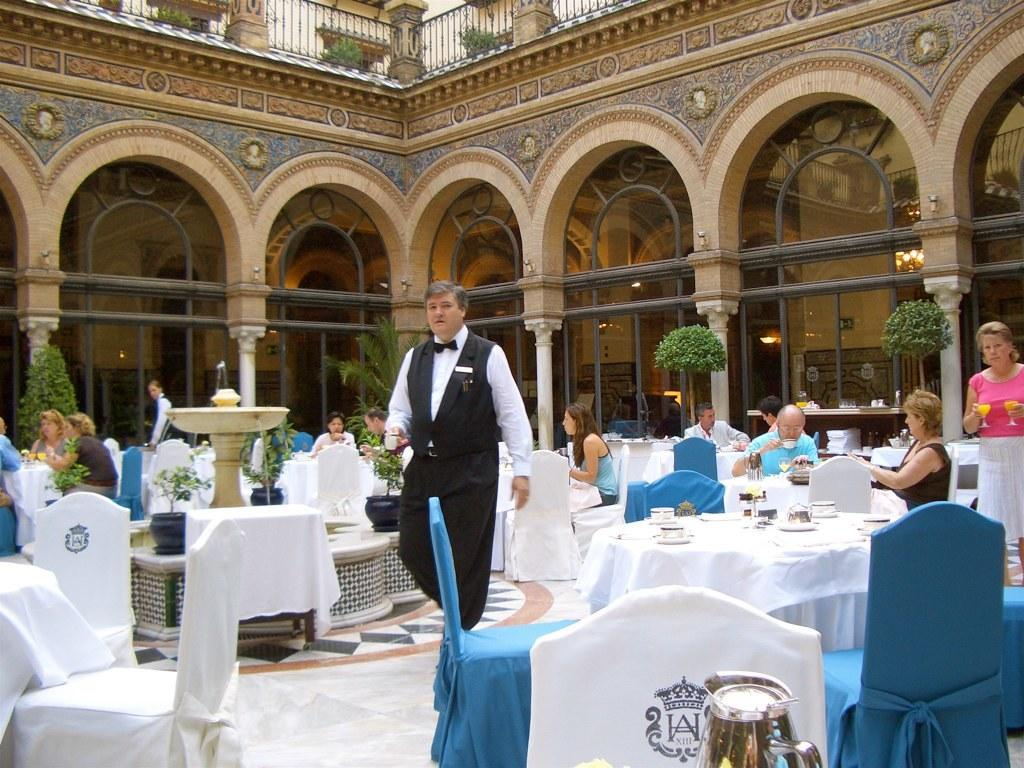What is the man in the image doing? The man is walking in the image. On what surface is the man walking? The man is walking on the floor. What is the position of the woman in the image? The woman is standing in the background of the image. What are some people in the image doing? There are people sitting in the image. What type of plant is present in the image? There is a small tree in the image. What is a feature of the setting in the image? There is a wall in the image. What type of exchange is taking place between the achiever and the fight in the image? There is no achiever, exchange, or fight present in the image. 